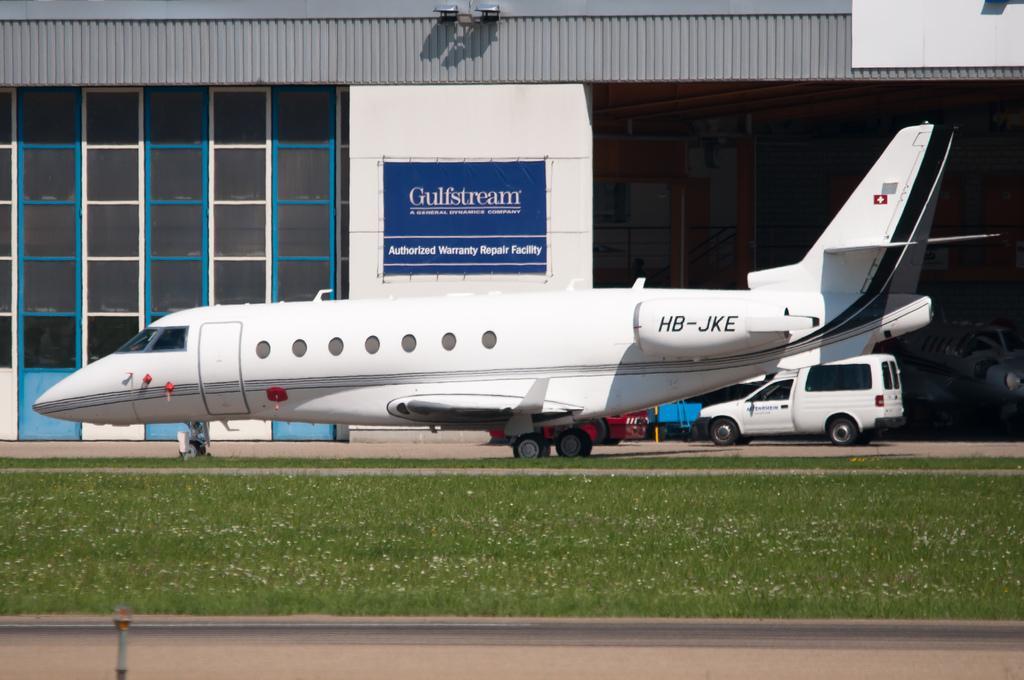Describe this image in one or two sentences. A plane with wheels on the ground. Land is covered with grass. Banner on the wall. Here we can see vehicles. 